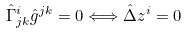Convert formula to latex. <formula><loc_0><loc_0><loc_500><loc_500>\hat { \Gamma } ^ { i } _ { j k } \hat { g } ^ { j k } = 0 \Longleftrightarrow \hat { \Delta } z ^ { i } = 0</formula> 